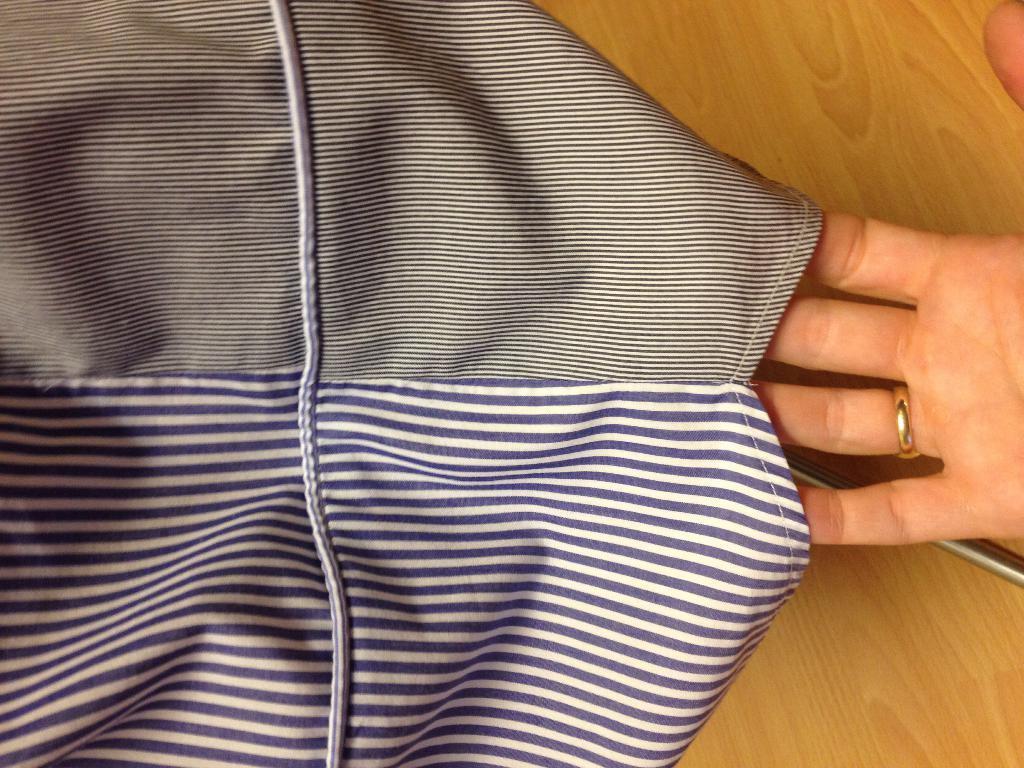Describe this image in one or two sentences. In this image I can see a cloth, a hand of a person and over here I can see a golden colour ring on this finger. 